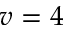Convert formula to latex. <formula><loc_0><loc_0><loc_500><loc_500>v = 4</formula> 